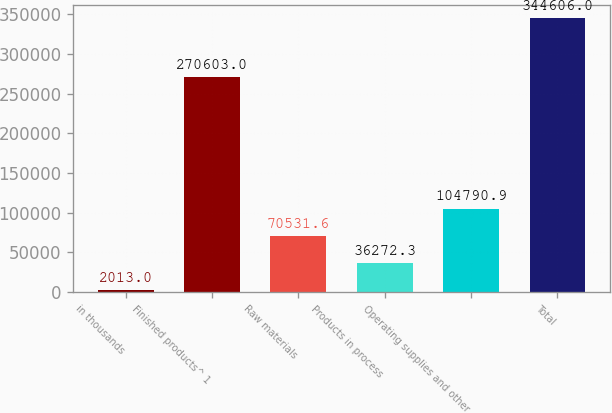Convert chart to OTSL. <chart><loc_0><loc_0><loc_500><loc_500><bar_chart><fcel>in thousands<fcel>Finished products^ 1<fcel>Raw materials<fcel>Products in process<fcel>Operating supplies and other<fcel>Total<nl><fcel>2013<fcel>270603<fcel>70531.6<fcel>36272.3<fcel>104791<fcel>344606<nl></chart> 